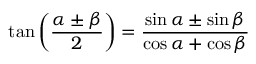Convert formula to latex. <formula><loc_0><loc_0><loc_500><loc_500>\tan \left ( { \frac { \alpha \pm \beta } { 2 } } \right ) = { \frac { \sin \alpha \pm \sin \beta } { \cos \alpha + \cos \beta } }</formula> 